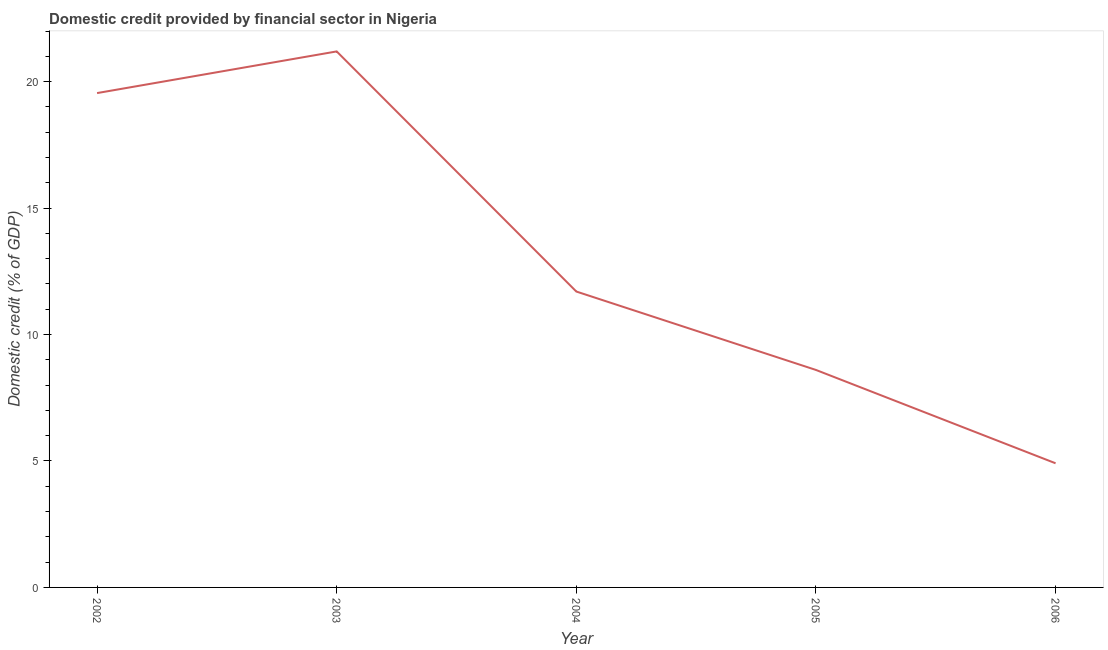What is the domestic credit provided by financial sector in 2003?
Your response must be concise. 21.2. Across all years, what is the maximum domestic credit provided by financial sector?
Provide a succinct answer. 21.2. Across all years, what is the minimum domestic credit provided by financial sector?
Ensure brevity in your answer.  4.91. What is the sum of the domestic credit provided by financial sector?
Keep it short and to the point. 65.96. What is the difference between the domestic credit provided by financial sector in 2002 and 2006?
Offer a very short reply. 14.64. What is the average domestic credit provided by financial sector per year?
Make the answer very short. 13.19. What is the median domestic credit provided by financial sector?
Provide a succinct answer. 11.7. What is the ratio of the domestic credit provided by financial sector in 2003 to that in 2004?
Provide a succinct answer. 1.81. What is the difference between the highest and the second highest domestic credit provided by financial sector?
Your answer should be compact. 1.65. Is the sum of the domestic credit provided by financial sector in 2005 and 2006 greater than the maximum domestic credit provided by financial sector across all years?
Your response must be concise. No. What is the difference between the highest and the lowest domestic credit provided by financial sector?
Provide a short and direct response. 16.29. In how many years, is the domestic credit provided by financial sector greater than the average domestic credit provided by financial sector taken over all years?
Make the answer very short. 2. How many lines are there?
Your response must be concise. 1. Does the graph contain any zero values?
Provide a succinct answer. No. What is the title of the graph?
Offer a terse response. Domestic credit provided by financial sector in Nigeria. What is the label or title of the Y-axis?
Offer a terse response. Domestic credit (% of GDP). What is the Domestic credit (% of GDP) of 2002?
Give a very brief answer. 19.55. What is the Domestic credit (% of GDP) of 2003?
Ensure brevity in your answer.  21.2. What is the Domestic credit (% of GDP) in 2004?
Offer a terse response. 11.7. What is the Domestic credit (% of GDP) of 2005?
Offer a very short reply. 8.6. What is the Domestic credit (% of GDP) in 2006?
Make the answer very short. 4.91. What is the difference between the Domestic credit (% of GDP) in 2002 and 2003?
Your answer should be very brief. -1.65. What is the difference between the Domestic credit (% of GDP) in 2002 and 2004?
Keep it short and to the point. 7.85. What is the difference between the Domestic credit (% of GDP) in 2002 and 2005?
Your response must be concise. 10.95. What is the difference between the Domestic credit (% of GDP) in 2002 and 2006?
Your answer should be very brief. 14.64. What is the difference between the Domestic credit (% of GDP) in 2003 and 2004?
Your answer should be very brief. 9.5. What is the difference between the Domestic credit (% of GDP) in 2003 and 2005?
Your answer should be very brief. 12.6. What is the difference between the Domestic credit (% of GDP) in 2003 and 2006?
Provide a succinct answer. 16.29. What is the difference between the Domestic credit (% of GDP) in 2004 and 2005?
Your answer should be very brief. 3.1. What is the difference between the Domestic credit (% of GDP) in 2004 and 2006?
Provide a short and direct response. 6.79. What is the difference between the Domestic credit (% of GDP) in 2005 and 2006?
Make the answer very short. 3.69. What is the ratio of the Domestic credit (% of GDP) in 2002 to that in 2003?
Make the answer very short. 0.92. What is the ratio of the Domestic credit (% of GDP) in 2002 to that in 2004?
Offer a terse response. 1.67. What is the ratio of the Domestic credit (% of GDP) in 2002 to that in 2005?
Provide a short and direct response. 2.27. What is the ratio of the Domestic credit (% of GDP) in 2002 to that in 2006?
Your answer should be very brief. 3.98. What is the ratio of the Domestic credit (% of GDP) in 2003 to that in 2004?
Your answer should be compact. 1.81. What is the ratio of the Domestic credit (% of GDP) in 2003 to that in 2005?
Provide a succinct answer. 2.46. What is the ratio of the Domestic credit (% of GDP) in 2003 to that in 2006?
Provide a short and direct response. 4.32. What is the ratio of the Domestic credit (% of GDP) in 2004 to that in 2005?
Give a very brief answer. 1.36. What is the ratio of the Domestic credit (% of GDP) in 2004 to that in 2006?
Provide a succinct answer. 2.38. What is the ratio of the Domestic credit (% of GDP) in 2005 to that in 2006?
Offer a very short reply. 1.75. 